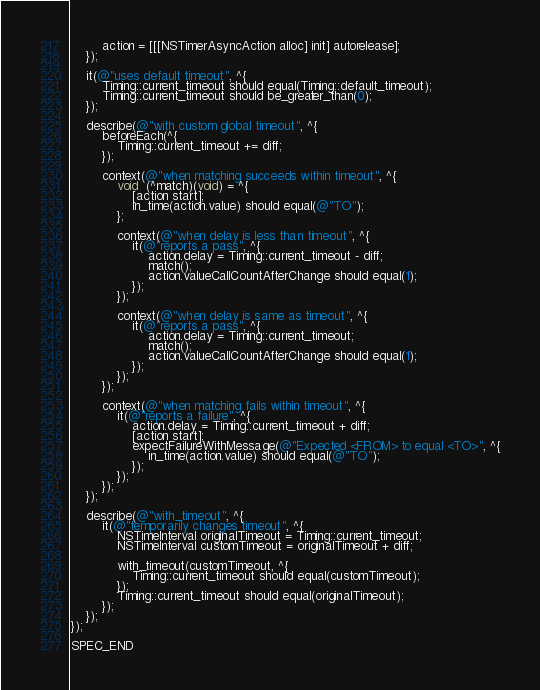<code> <loc_0><loc_0><loc_500><loc_500><_ObjectiveC_>        action = [[[NSTimerAsyncAction alloc] init] autorelease];
    });

    it(@"uses default timeout", ^{
        Timing::current_timeout should equal(Timing::default_timeout);
        Timing::current_timeout should be_greater_than(0);
    });

    describe(@"with custom global timeout", ^{
        beforeEach(^{
            Timing::current_timeout += diff;
        });

        context(@"when matching succeeds within timeout", ^{
            void  (^match)(void) = ^{
                [action start];
                in_time(action.value) should equal(@"TO");
            };

            context(@"when delay is less than timeout", ^{
                it(@"reports a pass", ^{
                    action.delay = Timing::current_timeout - diff;
                    match();
                    action.valueCallCountAfterChange should equal(1);
                });
            });

            context(@"when delay is same as timeout", ^{
                it(@"reports a pass", ^{
                    action.delay = Timing::current_timeout;
                    match();
                    action.valueCallCountAfterChange should equal(1);
                });
            });
        });

        context(@"when matching fails within timeout", ^{
            it(@"reports a failure", ^{
                action.delay = Timing::current_timeout + diff;
                [action start];
                expectFailureWithMessage(@"Expected <FROM> to equal <TO>", ^{
                    in_time(action.value) should equal(@"TO");
                });
            });
        });
    });

    describe(@"with_timeout", ^{
        it(@"temporarily changes timeout", ^{
            NSTimeInterval originalTimeout = Timing::current_timeout;
            NSTimeInterval customTimeout = originalTimeout + diff;

            with_timeout(customTimeout, ^{
                Timing::current_timeout should equal(customTimeout);
            });
            Timing::current_timeout should equal(originalTimeout);
        });
    });
});

SPEC_END
</code> 